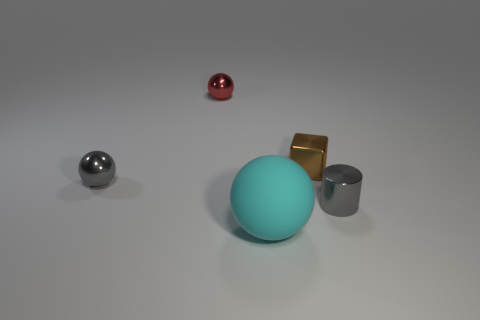Are there any big brown spheres that have the same material as the cyan object? no 